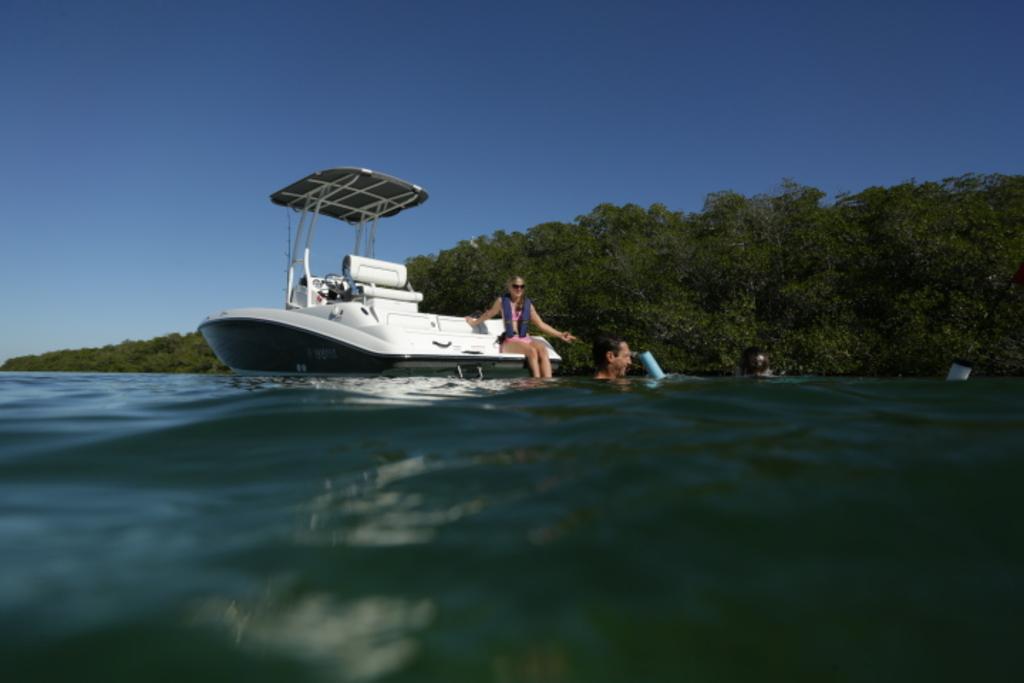Describe this image in one or two sentences. In this image there is the water. There is a boat on the water. There is a woman sitting on the boat. Beside the boat there are two people in the water. In the background there are trees. At the top there is the sky. 